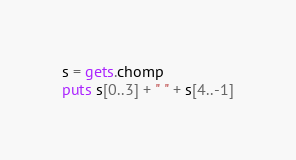<code> <loc_0><loc_0><loc_500><loc_500><_Ruby_>s = gets.chomp
puts s[0..3] + " " + s[4..-1]</code> 